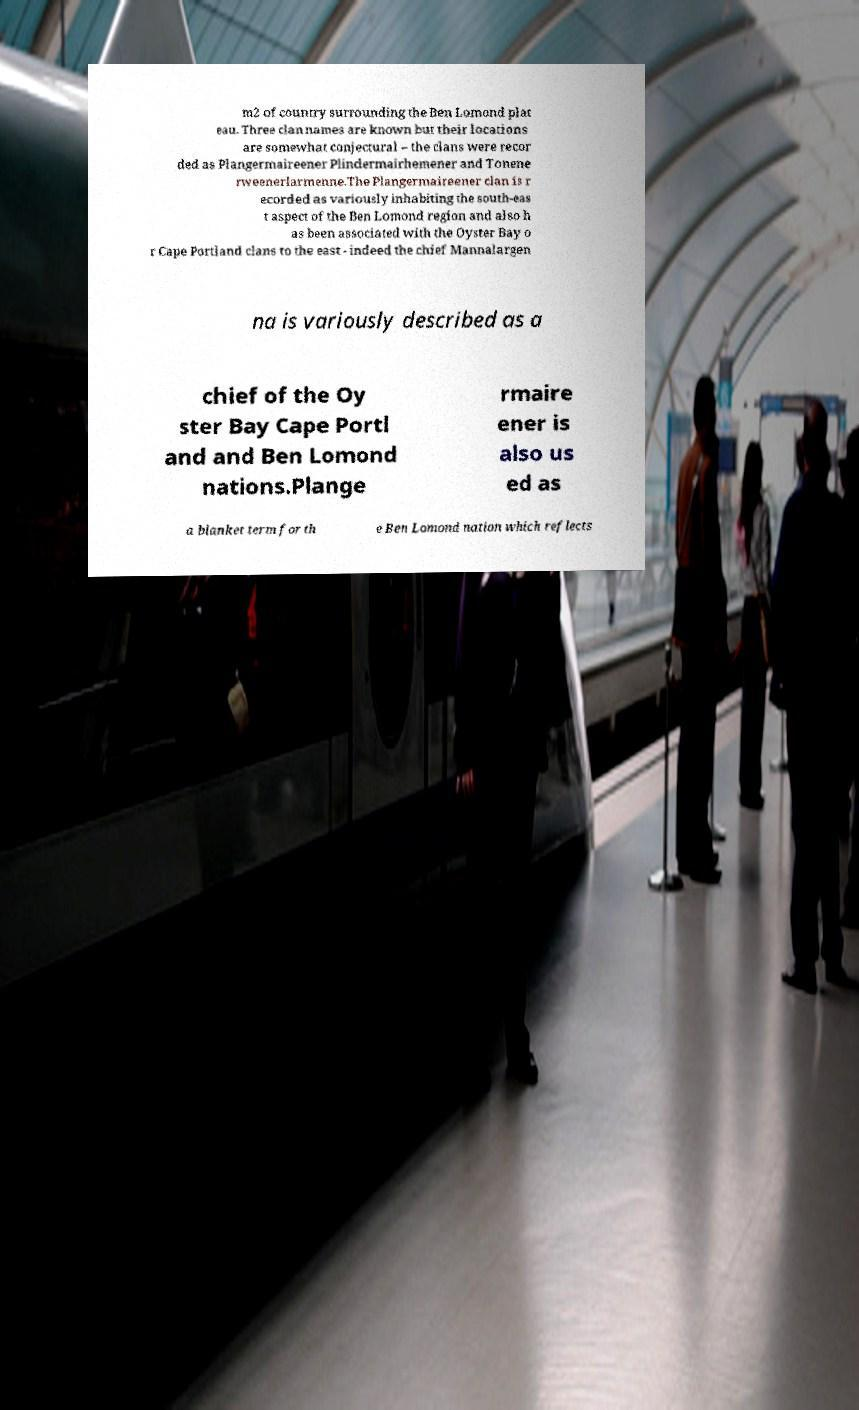Could you assist in decoding the text presented in this image and type it out clearly? m2 of country surrounding the Ben Lomond plat eau. Three clan names are known but their locations are somewhat conjectural – the clans were recor ded as Plangermaireener Plindermairhemener and Tonene rweenerlarmenne.The Plangermaireener clan is r ecorded as variously inhabiting the south-eas t aspect of the Ben Lomond region and also h as been associated with the Oyster Bay o r Cape Portland clans to the east - indeed the chief Mannalargen na is variously described as a chief of the Oy ster Bay Cape Portl and and Ben Lomond nations.Plange rmaire ener is also us ed as a blanket term for th e Ben Lomond nation which reflects 